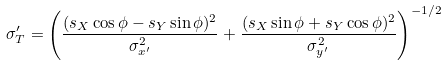Convert formula to latex. <formula><loc_0><loc_0><loc_500><loc_500>\sigma ^ { \prime } _ { T } = \left ( \frac { ( s _ { X } \cos \phi - s _ { Y } \sin \phi ) ^ { 2 } } { \sigma ^ { 2 } _ { x ^ { \prime } } } + \frac { ( s _ { X } \sin \phi + s _ { Y } \cos \phi ) ^ { 2 } } { \sigma ^ { 2 } _ { y ^ { \prime } } } \right ) ^ { - 1 / 2 }</formula> 